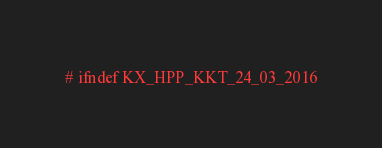Convert code to text. <code><loc_0><loc_0><loc_500><loc_500><_C++_>
# ifndef KX_HPP_KKT_24_03_2016</code> 